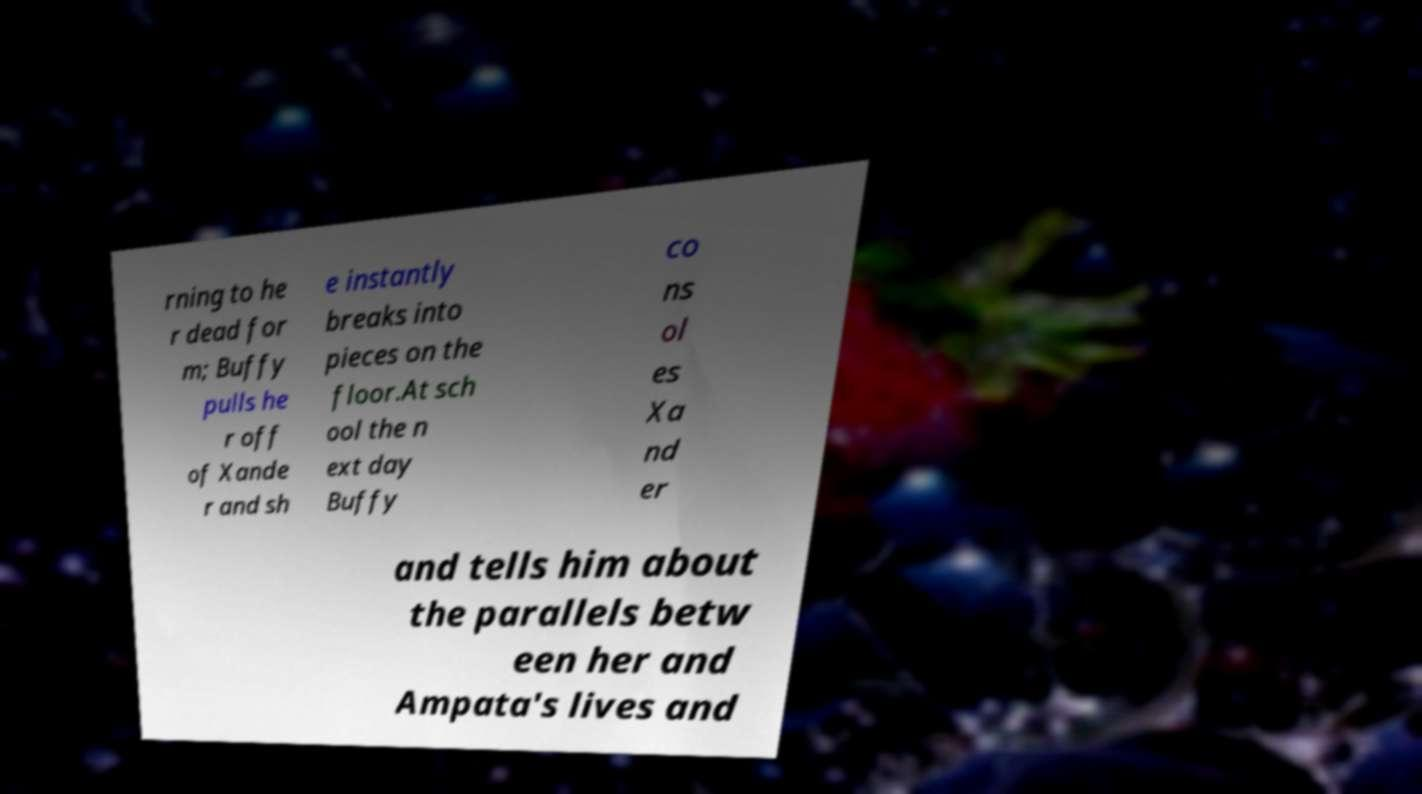Please read and relay the text visible in this image. What does it say? rning to he r dead for m; Buffy pulls he r off of Xande r and sh e instantly breaks into pieces on the floor.At sch ool the n ext day Buffy co ns ol es Xa nd er and tells him about the parallels betw een her and Ampata's lives and 